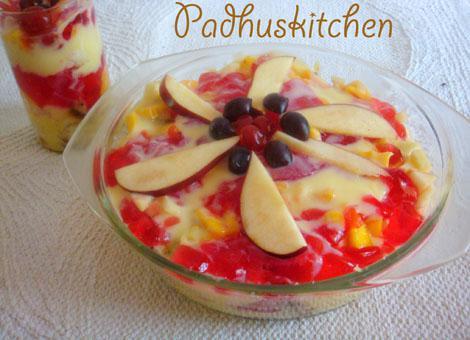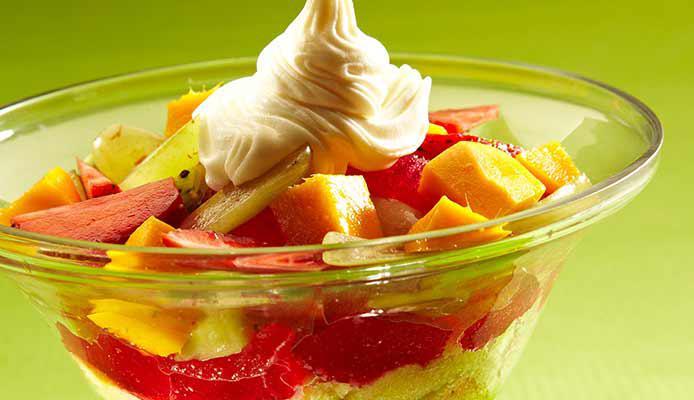The first image is the image on the left, the second image is the image on the right. For the images shown, is this caption "The left image features a trifle garnished with thin apple slices." true? Answer yes or no. Yes. 